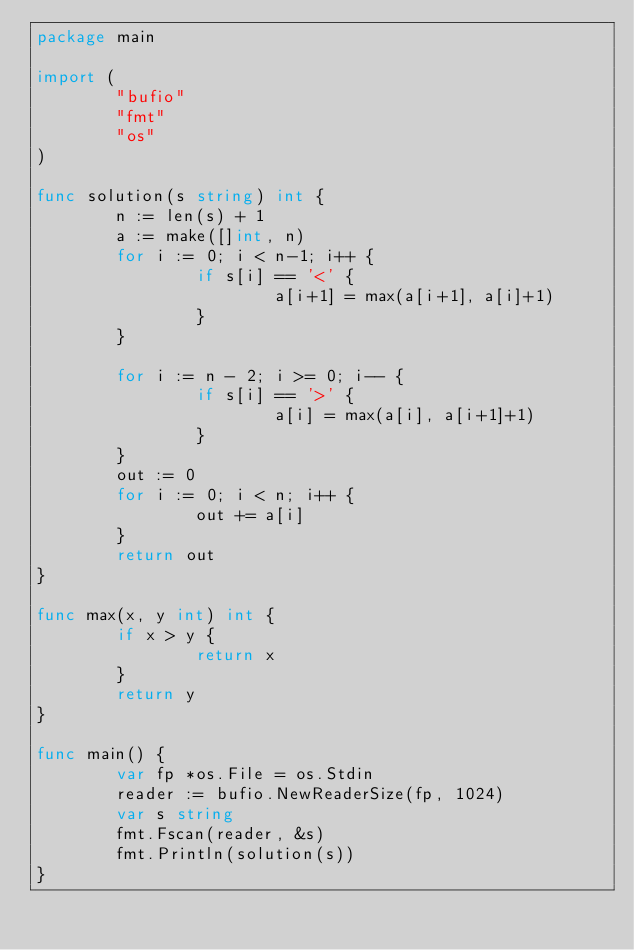Convert code to text. <code><loc_0><loc_0><loc_500><loc_500><_Go_>package main

import (
        "bufio"
        "fmt"
        "os"
)

func solution(s string) int {
        n := len(s) + 1
        a := make([]int, n)
        for i := 0; i < n-1; i++ {
                if s[i] == '<' {
                        a[i+1] = max(a[i+1], a[i]+1)
                }
        }

        for i := n - 2; i >= 0; i-- {
                if s[i] == '>' {
                        a[i] = max(a[i], a[i+1]+1)
                }
        }
        out := 0
        for i := 0; i < n; i++ {
                out += a[i]
        }
        return out
}

func max(x, y int) int {
        if x > y {
                return x
        }
        return y
}

func main() {
        var fp *os.File = os.Stdin
        reader := bufio.NewReaderSize(fp, 1024)
        var s string
        fmt.Fscan(reader, &s)
        fmt.Println(solution(s))
}</code> 